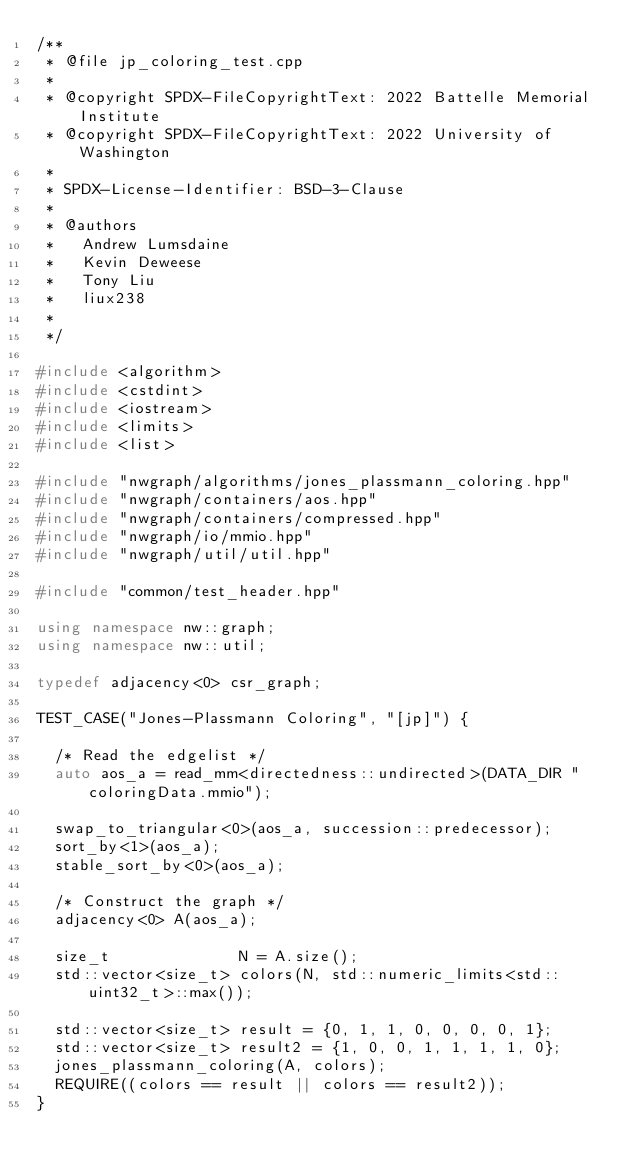<code> <loc_0><loc_0><loc_500><loc_500><_C++_>/**
 * @file jp_coloring_test.cpp
 *
 * @copyright SPDX-FileCopyrightText: 2022 Battelle Memorial Institute
 * @copyright SPDX-FileCopyrightText: 2022 University of Washington
 *
 * SPDX-License-Identifier: BSD-3-Clause
 *
 * @authors
 *   Andrew Lumsdaine
 *   Kevin Deweese
 *   Tony Liu
 *   liux238
 *
 */

#include <algorithm>
#include <cstdint>
#include <iostream>
#include <limits>
#include <list>

#include "nwgraph/algorithms/jones_plassmann_coloring.hpp"
#include "nwgraph/containers/aos.hpp"
#include "nwgraph/containers/compressed.hpp"
#include "nwgraph/io/mmio.hpp"
#include "nwgraph/util/util.hpp"

#include "common/test_header.hpp"

using namespace nw::graph;
using namespace nw::util;

typedef adjacency<0> csr_graph;

TEST_CASE("Jones-Plassmann Coloring", "[jp]") {

  /* Read the edgelist */
  auto aos_a = read_mm<directedness::undirected>(DATA_DIR "coloringData.mmio");

  swap_to_triangular<0>(aos_a, succession::predecessor);
  sort_by<1>(aos_a);
  stable_sort_by<0>(aos_a);

  /* Construct the graph */
  adjacency<0> A(aos_a);

  size_t              N = A.size();
  std::vector<size_t> colors(N, std::numeric_limits<std::uint32_t>::max());

  std::vector<size_t> result = {0, 1, 1, 0, 0, 0, 0, 1};
  std::vector<size_t> result2 = {1, 0, 0, 1, 1, 1, 1, 0};
  jones_plassmann_coloring(A, colors);
  REQUIRE((colors == result || colors == result2));
}
</code> 